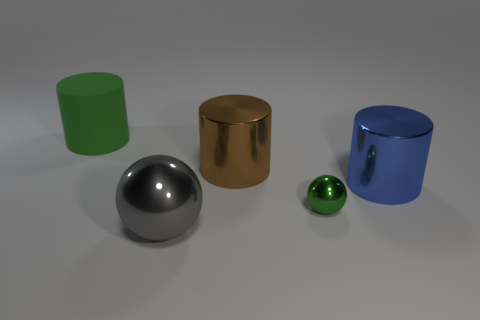Add 2 small metal spheres. How many objects exist? 7 Subtract all cylinders. How many objects are left? 2 Subtract all large green cylinders. Subtract all gray spheres. How many objects are left? 3 Add 4 big gray things. How many big gray things are left? 5 Add 5 green spheres. How many green spheres exist? 6 Subtract 1 green balls. How many objects are left? 4 